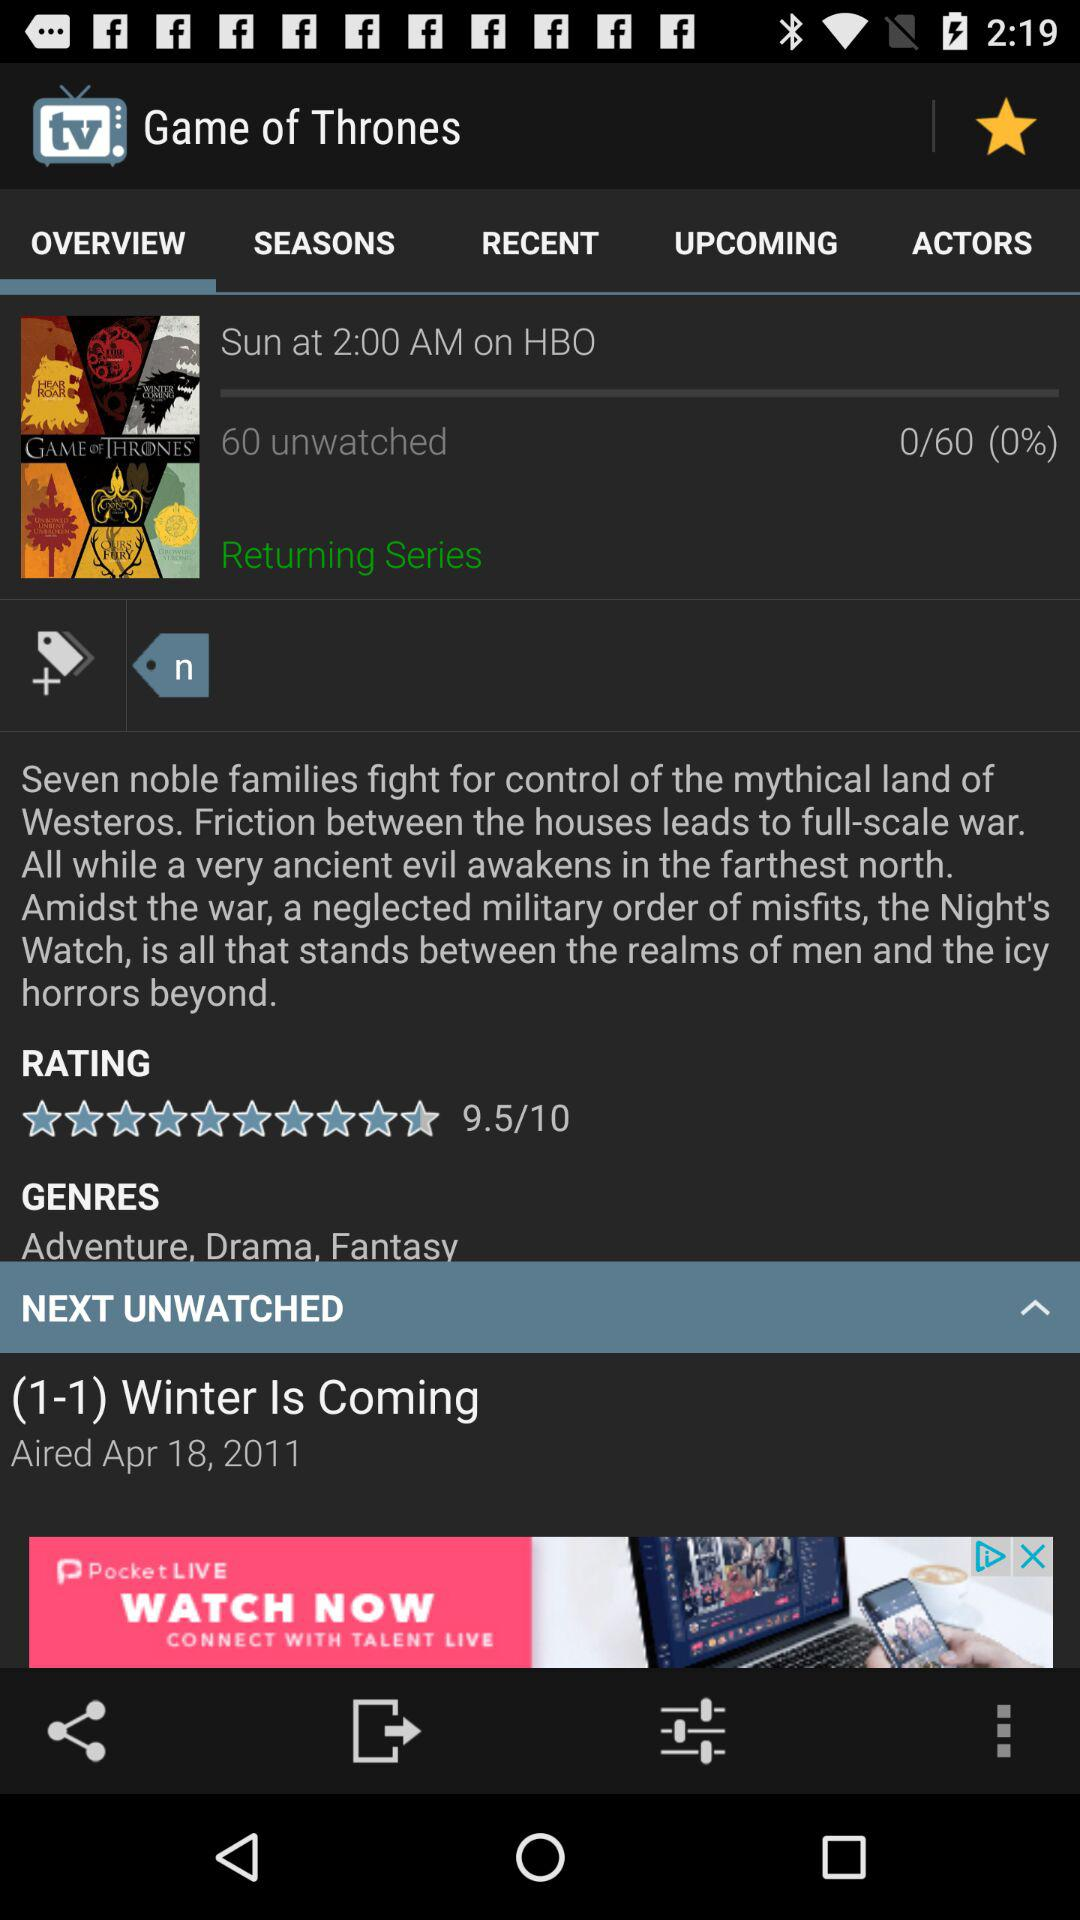What is the rating for the "Game of Thrones" TV series? The rating for the "Game of Thrones" TV series is 9.5. 